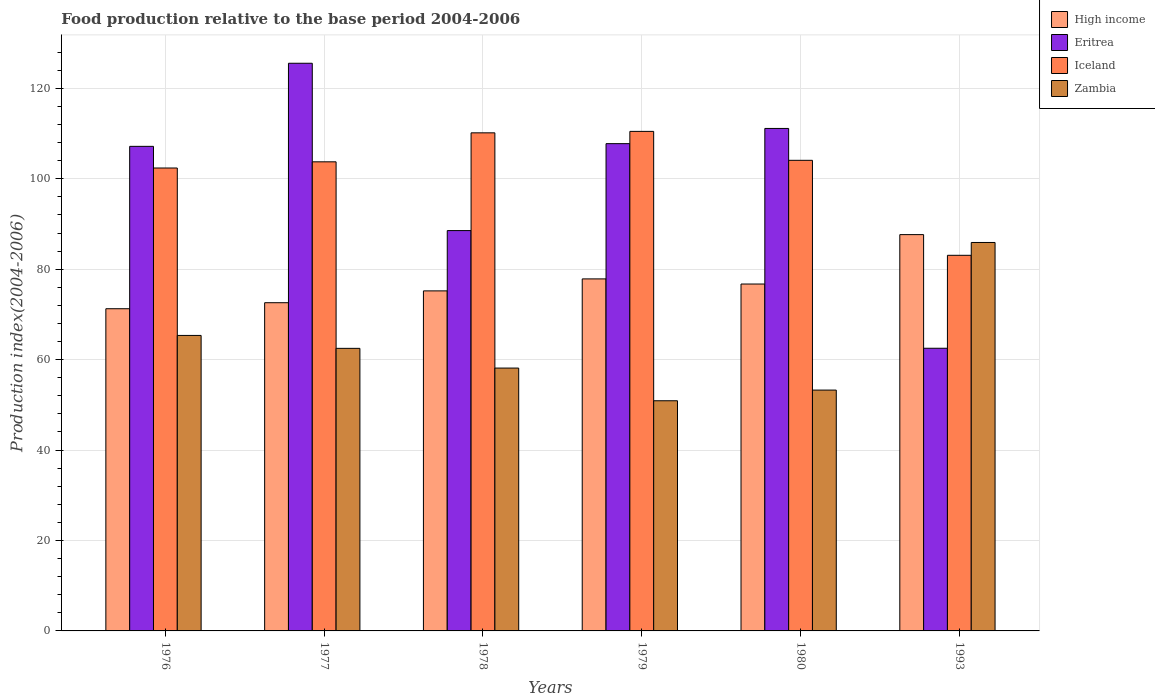Are the number of bars per tick equal to the number of legend labels?
Offer a very short reply. Yes. Are the number of bars on each tick of the X-axis equal?
Your response must be concise. Yes. What is the label of the 3rd group of bars from the left?
Make the answer very short. 1978. What is the food production index in Iceland in 1979?
Your response must be concise. 110.49. Across all years, what is the maximum food production index in Eritrea?
Your response must be concise. 125.56. Across all years, what is the minimum food production index in Zambia?
Your answer should be very brief. 50.91. In which year was the food production index in High income minimum?
Provide a succinct answer. 1976. What is the total food production index in High income in the graph?
Provide a succinct answer. 461.32. What is the difference between the food production index in Zambia in 1977 and that in 1978?
Keep it short and to the point. 4.36. What is the difference between the food production index in Zambia in 1978 and the food production index in High income in 1980?
Keep it short and to the point. -18.59. What is the average food production index in Zambia per year?
Ensure brevity in your answer.  62.68. In the year 1978, what is the difference between the food production index in Iceland and food production index in High income?
Your response must be concise. 34.96. What is the ratio of the food production index in Eritrea in 1978 to that in 1980?
Your response must be concise. 0.8. Is the food production index in High income in 1976 less than that in 1978?
Keep it short and to the point. Yes. What is the difference between the highest and the second highest food production index in Iceland?
Your response must be concise. 0.32. What is the difference between the highest and the lowest food production index in Eritrea?
Ensure brevity in your answer.  63.04. Is the sum of the food production index in Zambia in 1976 and 1977 greater than the maximum food production index in Iceland across all years?
Keep it short and to the point. Yes. How many years are there in the graph?
Offer a terse response. 6. Does the graph contain any zero values?
Your answer should be very brief. No. How many legend labels are there?
Provide a short and direct response. 4. What is the title of the graph?
Provide a short and direct response. Food production relative to the base period 2004-2006. What is the label or title of the Y-axis?
Your response must be concise. Production index(2004-2006). What is the Production index(2004-2006) in High income in 1976?
Offer a terse response. 71.26. What is the Production index(2004-2006) in Eritrea in 1976?
Your response must be concise. 107.18. What is the Production index(2004-2006) of Iceland in 1976?
Offer a very short reply. 102.39. What is the Production index(2004-2006) in Zambia in 1976?
Keep it short and to the point. 65.36. What is the Production index(2004-2006) of High income in 1977?
Keep it short and to the point. 72.6. What is the Production index(2004-2006) of Eritrea in 1977?
Your answer should be compact. 125.56. What is the Production index(2004-2006) in Iceland in 1977?
Provide a short and direct response. 103.76. What is the Production index(2004-2006) of Zambia in 1977?
Make the answer very short. 62.5. What is the Production index(2004-2006) in High income in 1978?
Ensure brevity in your answer.  75.21. What is the Production index(2004-2006) in Eritrea in 1978?
Your answer should be compact. 88.55. What is the Production index(2004-2006) in Iceland in 1978?
Your answer should be compact. 110.17. What is the Production index(2004-2006) of Zambia in 1978?
Ensure brevity in your answer.  58.14. What is the Production index(2004-2006) of High income in 1979?
Offer a terse response. 77.86. What is the Production index(2004-2006) in Eritrea in 1979?
Your answer should be compact. 107.78. What is the Production index(2004-2006) of Iceland in 1979?
Make the answer very short. 110.49. What is the Production index(2004-2006) in Zambia in 1979?
Ensure brevity in your answer.  50.91. What is the Production index(2004-2006) of High income in 1980?
Provide a succinct answer. 76.73. What is the Production index(2004-2006) in Eritrea in 1980?
Your answer should be very brief. 111.14. What is the Production index(2004-2006) in Iceland in 1980?
Offer a terse response. 104.09. What is the Production index(2004-2006) in Zambia in 1980?
Keep it short and to the point. 53.27. What is the Production index(2004-2006) in High income in 1993?
Keep it short and to the point. 87.66. What is the Production index(2004-2006) in Eritrea in 1993?
Your answer should be compact. 62.52. What is the Production index(2004-2006) of Iceland in 1993?
Your response must be concise. 83.08. What is the Production index(2004-2006) in Zambia in 1993?
Ensure brevity in your answer.  85.92. Across all years, what is the maximum Production index(2004-2006) of High income?
Your response must be concise. 87.66. Across all years, what is the maximum Production index(2004-2006) of Eritrea?
Provide a succinct answer. 125.56. Across all years, what is the maximum Production index(2004-2006) of Iceland?
Your answer should be very brief. 110.49. Across all years, what is the maximum Production index(2004-2006) of Zambia?
Make the answer very short. 85.92. Across all years, what is the minimum Production index(2004-2006) in High income?
Your answer should be very brief. 71.26. Across all years, what is the minimum Production index(2004-2006) of Eritrea?
Provide a short and direct response. 62.52. Across all years, what is the minimum Production index(2004-2006) of Iceland?
Ensure brevity in your answer.  83.08. Across all years, what is the minimum Production index(2004-2006) of Zambia?
Your response must be concise. 50.91. What is the total Production index(2004-2006) of High income in the graph?
Ensure brevity in your answer.  461.32. What is the total Production index(2004-2006) in Eritrea in the graph?
Keep it short and to the point. 602.73. What is the total Production index(2004-2006) of Iceland in the graph?
Keep it short and to the point. 613.98. What is the total Production index(2004-2006) of Zambia in the graph?
Offer a terse response. 376.1. What is the difference between the Production index(2004-2006) of High income in 1976 and that in 1977?
Provide a succinct answer. -1.33. What is the difference between the Production index(2004-2006) in Eritrea in 1976 and that in 1977?
Offer a very short reply. -18.38. What is the difference between the Production index(2004-2006) in Iceland in 1976 and that in 1977?
Provide a succinct answer. -1.37. What is the difference between the Production index(2004-2006) in Zambia in 1976 and that in 1977?
Ensure brevity in your answer.  2.86. What is the difference between the Production index(2004-2006) in High income in 1976 and that in 1978?
Offer a terse response. -3.95. What is the difference between the Production index(2004-2006) of Eritrea in 1976 and that in 1978?
Your answer should be compact. 18.63. What is the difference between the Production index(2004-2006) of Iceland in 1976 and that in 1978?
Offer a terse response. -7.78. What is the difference between the Production index(2004-2006) in Zambia in 1976 and that in 1978?
Your answer should be compact. 7.22. What is the difference between the Production index(2004-2006) in High income in 1976 and that in 1979?
Keep it short and to the point. -6.6. What is the difference between the Production index(2004-2006) of Iceland in 1976 and that in 1979?
Your response must be concise. -8.1. What is the difference between the Production index(2004-2006) in Zambia in 1976 and that in 1979?
Your response must be concise. 14.45. What is the difference between the Production index(2004-2006) in High income in 1976 and that in 1980?
Provide a short and direct response. -5.47. What is the difference between the Production index(2004-2006) in Eritrea in 1976 and that in 1980?
Provide a short and direct response. -3.96. What is the difference between the Production index(2004-2006) in Iceland in 1976 and that in 1980?
Provide a succinct answer. -1.7. What is the difference between the Production index(2004-2006) in Zambia in 1976 and that in 1980?
Your answer should be compact. 12.09. What is the difference between the Production index(2004-2006) in High income in 1976 and that in 1993?
Offer a terse response. -16.39. What is the difference between the Production index(2004-2006) in Eritrea in 1976 and that in 1993?
Your answer should be compact. 44.66. What is the difference between the Production index(2004-2006) in Iceland in 1976 and that in 1993?
Keep it short and to the point. 19.31. What is the difference between the Production index(2004-2006) of Zambia in 1976 and that in 1993?
Keep it short and to the point. -20.56. What is the difference between the Production index(2004-2006) of High income in 1977 and that in 1978?
Ensure brevity in your answer.  -2.62. What is the difference between the Production index(2004-2006) in Eritrea in 1977 and that in 1978?
Provide a succinct answer. 37.01. What is the difference between the Production index(2004-2006) in Iceland in 1977 and that in 1978?
Keep it short and to the point. -6.41. What is the difference between the Production index(2004-2006) of Zambia in 1977 and that in 1978?
Your answer should be very brief. 4.36. What is the difference between the Production index(2004-2006) of High income in 1977 and that in 1979?
Keep it short and to the point. -5.27. What is the difference between the Production index(2004-2006) of Eritrea in 1977 and that in 1979?
Provide a succinct answer. 17.78. What is the difference between the Production index(2004-2006) of Iceland in 1977 and that in 1979?
Provide a short and direct response. -6.73. What is the difference between the Production index(2004-2006) in Zambia in 1977 and that in 1979?
Offer a very short reply. 11.59. What is the difference between the Production index(2004-2006) in High income in 1977 and that in 1980?
Give a very brief answer. -4.14. What is the difference between the Production index(2004-2006) in Eritrea in 1977 and that in 1980?
Provide a succinct answer. 14.42. What is the difference between the Production index(2004-2006) of Iceland in 1977 and that in 1980?
Ensure brevity in your answer.  -0.33. What is the difference between the Production index(2004-2006) of Zambia in 1977 and that in 1980?
Provide a succinct answer. 9.23. What is the difference between the Production index(2004-2006) of High income in 1977 and that in 1993?
Keep it short and to the point. -15.06. What is the difference between the Production index(2004-2006) in Eritrea in 1977 and that in 1993?
Provide a succinct answer. 63.04. What is the difference between the Production index(2004-2006) of Iceland in 1977 and that in 1993?
Your response must be concise. 20.68. What is the difference between the Production index(2004-2006) in Zambia in 1977 and that in 1993?
Provide a short and direct response. -23.42. What is the difference between the Production index(2004-2006) in High income in 1978 and that in 1979?
Provide a short and direct response. -2.65. What is the difference between the Production index(2004-2006) of Eritrea in 1978 and that in 1979?
Make the answer very short. -19.23. What is the difference between the Production index(2004-2006) of Iceland in 1978 and that in 1979?
Your response must be concise. -0.32. What is the difference between the Production index(2004-2006) in Zambia in 1978 and that in 1979?
Provide a short and direct response. 7.23. What is the difference between the Production index(2004-2006) in High income in 1978 and that in 1980?
Make the answer very short. -1.52. What is the difference between the Production index(2004-2006) of Eritrea in 1978 and that in 1980?
Offer a very short reply. -22.59. What is the difference between the Production index(2004-2006) of Iceland in 1978 and that in 1980?
Your answer should be compact. 6.08. What is the difference between the Production index(2004-2006) of Zambia in 1978 and that in 1980?
Provide a short and direct response. 4.87. What is the difference between the Production index(2004-2006) of High income in 1978 and that in 1993?
Offer a very short reply. -12.45. What is the difference between the Production index(2004-2006) of Eritrea in 1978 and that in 1993?
Ensure brevity in your answer.  26.03. What is the difference between the Production index(2004-2006) of Iceland in 1978 and that in 1993?
Give a very brief answer. 27.09. What is the difference between the Production index(2004-2006) in Zambia in 1978 and that in 1993?
Your response must be concise. -27.78. What is the difference between the Production index(2004-2006) of High income in 1979 and that in 1980?
Keep it short and to the point. 1.13. What is the difference between the Production index(2004-2006) in Eritrea in 1979 and that in 1980?
Offer a very short reply. -3.36. What is the difference between the Production index(2004-2006) of Zambia in 1979 and that in 1980?
Provide a succinct answer. -2.36. What is the difference between the Production index(2004-2006) in High income in 1979 and that in 1993?
Give a very brief answer. -9.79. What is the difference between the Production index(2004-2006) of Eritrea in 1979 and that in 1993?
Give a very brief answer. 45.26. What is the difference between the Production index(2004-2006) in Iceland in 1979 and that in 1993?
Keep it short and to the point. 27.41. What is the difference between the Production index(2004-2006) of Zambia in 1979 and that in 1993?
Your answer should be compact. -35.01. What is the difference between the Production index(2004-2006) in High income in 1980 and that in 1993?
Offer a very short reply. -10.93. What is the difference between the Production index(2004-2006) in Eritrea in 1980 and that in 1993?
Ensure brevity in your answer.  48.62. What is the difference between the Production index(2004-2006) of Iceland in 1980 and that in 1993?
Offer a terse response. 21.01. What is the difference between the Production index(2004-2006) of Zambia in 1980 and that in 1993?
Keep it short and to the point. -32.65. What is the difference between the Production index(2004-2006) in High income in 1976 and the Production index(2004-2006) in Eritrea in 1977?
Provide a succinct answer. -54.3. What is the difference between the Production index(2004-2006) in High income in 1976 and the Production index(2004-2006) in Iceland in 1977?
Keep it short and to the point. -32.5. What is the difference between the Production index(2004-2006) of High income in 1976 and the Production index(2004-2006) of Zambia in 1977?
Offer a terse response. 8.76. What is the difference between the Production index(2004-2006) of Eritrea in 1976 and the Production index(2004-2006) of Iceland in 1977?
Your response must be concise. 3.42. What is the difference between the Production index(2004-2006) in Eritrea in 1976 and the Production index(2004-2006) in Zambia in 1977?
Ensure brevity in your answer.  44.68. What is the difference between the Production index(2004-2006) of Iceland in 1976 and the Production index(2004-2006) of Zambia in 1977?
Give a very brief answer. 39.89. What is the difference between the Production index(2004-2006) in High income in 1976 and the Production index(2004-2006) in Eritrea in 1978?
Keep it short and to the point. -17.29. What is the difference between the Production index(2004-2006) of High income in 1976 and the Production index(2004-2006) of Iceland in 1978?
Keep it short and to the point. -38.91. What is the difference between the Production index(2004-2006) in High income in 1976 and the Production index(2004-2006) in Zambia in 1978?
Make the answer very short. 13.12. What is the difference between the Production index(2004-2006) of Eritrea in 1976 and the Production index(2004-2006) of Iceland in 1978?
Ensure brevity in your answer.  -2.99. What is the difference between the Production index(2004-2006) in Eritrea in 1976 and the Production index(2004-2006) in Zambia in 1978?
Your response must be concise. 49.04. What is the difference between the Production index(2004-2006) in Iceland in 1976 and the Production index(2004-2006) in Zambia in 1978?
Offer a terse response. 44.25. What is the difference between the Production index(2004-2006) in High income in 1976 and the Production index(2004-2006) in Eritrea in 1979?
Ensure brevity in your answer.  -36.52. What is the difference between the Production index(2004-2006) in High income in 1976 and the Production index(2004-2006) in Iceland in 1979?
Your answer should be compact. -39.23. What is the difference between the Production index(2004-2006) in High income in 1976 and the Production index(2004-2006) in Zambia in 1979?
Ensure brevity in your answer.  20.35. What is the difference between the Production index(2004-2006) of Eritrea in 1976 and the Production index(2004-2006) of Iceland in 1979?
Ensure brevity in your answer.  -3.31. What is the difference between the Production index(2004-2006) in Eritrea in 1976 and the Production index(2004-2006) in Zambia in 1979?
Your answer should be compact. 56.27. What is the difference between the Production index(2004-2006) in Iceland in 1976 and the Production index(2004-2006) in Zambia in 1979?
Your answer should be very brief. 51.48. What is the difference between the Production index(2004-2006) in High income in 1976 and the Production index(2004-2006) in Eritrea in 1980?
Your answer should be compact. -39.88. What is the difference between the Production index(2004-2006) of High income in 1976 and the Production index(2004-2006) of Iceland in 1980?
Your answer should be compact. -32.83. What is the difference between the Production index(2004-2006) in High income in 1976 and the Production index(2004-2006) in Zambia in 1980?
Keep it short and to the point. 17.99. What is the difference between the Production index(2004-2006) of Eritrea in 1976 and the Production index(2004-2006) of Iceland in 1980?
Provide a short and direct response. 3.09. What is the difference between the Production index(2004-2006) of Eritrea in 1976 and the Production index(2004-2006) of Zambia in 1980?
Provide a succinct answer. 53.91. What is the difference between the Production index(2004-2006) in Iceland in 1976 and the Production index(2004-2006) in Zambia in 1980?
Give a very brief answer. 49.12. What is the difference between the Production index(2004-2006) of High income in 1976 and the Production index(2004-2006) of Eritrea in 1993?
Give a very brief answer. 8.74. What is the difference between the Production index(2004-2006) of High income in 1976 and the Production index(2004-2006) of Iceland in 1993?
Give a very brief answer. -11.82. What is the difference between the Production index(2004-2006) in High income in 1976 and the Production index(2004-2006) in Zambia in 1993?
Your response must be concise. -14.66. What is the difference between the Production index(2004-2006) of Eritrea in 1976 and the Production index(2004-2006) of Iceland in 1993?
Your response must be concise. 24.1. What is the difference between the Production index(2004-2006) of Eritrea in 1976 and the Production index(2004-2006) of Zambia in 1993?
Give a very brief answer. 21.26. What is the difference between the Production index(2004-2006) in Iceland in 1976 and the Production index(2004-2006) in Zambia in 1993?
Make the answer very short. 16.47. What is the difference between the Production index(2004-2006) of High income in 1977 and the Production index(2004-2006) of Eritrea in 1978?
Offer a terse response. -15.95. What is the difference between the Production index(2004-2006) of High income in 1977 and the Production index(2004-2006) of Iceland in 1978?
Make the answer very short. -37.57. What is the difference between the Production index(2004-2006) in High income in 1977 and the Production index(2004-2006) in Zambia in 1978?
Your response must be concise. 14.46. What is the difference between the Production index(2004-2006) in Eritrea in 1977 and the Production index(2004-2006) in Iceland in 1978?
Your answer should be very brief. 15.39. What is the difference between the Production index(2004-2006) of Eritrea in 1977 and the Production index(2004-2006) of Zambia in 1978?
Provide a succinct answer. 67.42. What is the difference between the Production index(2004-2006) of Iceland in 1977 and the Production index(2004-2006) of Zambia in 1978?
Your answer should be very brief. 45.62. What is the difference between the Production index(2004-2006) of High income in 1977 and the Production index(2004-2006) of Eritrea in 1979?
Provide a short and direct response. -35.18. What is the difference between the Production index(2004-2006) of High income in 1977 and the Production index(2004-2006) of Iceland in 1979?
Provide a short and direct response. -37.89. What is the difference between the Production index(2004-2006) in High income in 1977 and the Production index(2004-2006) in Zambia in 1979?
Your answer should be very brief. 21.69. What is the difference between the Production index(2004-2006) in Eritrea in 1977 and the Production index(2004-2006) in Iceland in 1979?
Provide a succinct answer. 15.07. What is the difference between the Production index(2004-2006) of Eritrea in 1977 and the Production index(2004-2006) of Zambia in 1979?
Give a very brief answer. 74.65. What is the difference between the Production index(2004-2006) of Iceland in 1977 and the Production index(2004-2006) of Zambia in 1979?
Provide a short and direct response. 52.85. What is the difference between the Production index(2004-2006) of High income in 1977 and the Production index(2004-2006) of Eritrea in 1980?
Your answer should be very brief. -38.54. What is the difference between the Production index(2004-2006) of High income in 1977 and the Production index(2004-2006) of Iceland in 1980?
Provide a succinct answer. -31.49. What is the difference between the Production index(2004-2006) in High income in 1977 and the Production index(2004-2006) in Zambia in 1980?
Your response must be concise. 19.33. What is the difference between the Production index(2004-2006) of Eritrea in 1977 and the Production index(2004-2006) of Iceland in 1980?
Your response must be concise. 21.47. What is the difference between the Production index(2004-2006) in Eritrea in 1977 and the Production index(2004-2006) in Zambia in 1980?
Keep it short and to the point. 72.29. What is the difference between the Production index(2004-2006) in Iceland in 1977 and the Production index(2004-2006) in Zambia in 1980?
Offer a terse response. 50.49. What is the difference between the Production index(2004-2006) of High income in 1977 and the Production index(2004-2006) of Eritrea in 1993?
Provide a succinct answer. 10.08. What is the difference between the Production index(2004-2006) in High income in 1977 and the Production index(2004-2006) in Iceland in 1993?
Give a very brief answer. -10.48. What is the difference between the Production index(2004-2006) in High income in 1977 and the Production index(2004-2006) in Zambia in 1993?
Your response must be concise. -13.32. What is the difference between the Production index(2004-2006) in Eritrea in 1977 and the Production index(2004-2006) in Iceland in 1993?
Your response must be concise. 42.48. What is the difference between the Production index(2004-2006) of Eritrea in 1977 and the Production index(2004-2006) of Zambia in 1993?
Keep it short and to the point. 39.64. What is the difference between the Production index(2004-2006) of Iceland in 1977 and the Production index(2004-2006) of Zambia in 1993?
Provide a short and direct response. 17.84. What is the difference between the Production index(2004-2006) in High income in 1978 and the Production index(2004-2006) in Eritrea in 1979?
Keep it short and to the point. -32.57. What is the difference between the Production index(2004-2006) of High income in 1978 and the Production index(2004-2006) of Iceland in 1979?
Provide a succinct answer. -35.28. What is the difference between the Production index(2004-2006) of High income in 1978 and the Production index(2004-2006) of Zambia in 1979?
Give a very brief answer. 24.3. What is the difference between the Production index(2004-2006) in Eritrea in 1978 and the Production index(2004-2006) in Iceland in 1979?
Your answer should be very brief. -21.94. What is the difference between the Production index(2004-2006) in Eritrea in 1978 and the Production index(2004-2006) in Zambia in 1979?
Offer a terse response. 37.64. What is the difference between the Production index(2004-2006) in Iceland in 1978 and the Production index(2004-2006) in Zambia in 1979?
Provide a succinct answer. 59.26. What is the difference between the Production index(2004-2006) of High income in 1978 and the Production index(2004-2006) of Eritrea in 1980?
Provide a succinct answer. -35.93. What is the difference between the Production index(2004-2006) of High income in 1978 and the Production index(2004-2006) of Iceland in 1980?
Offer a very short reply. -28.88. What is the difference between the Production index(2004-2006) in High income in 1978 and the Production index(2004-2006) in Zambia in 1980?
Provide a short and direct response. 21.94. What is the difference between the Production index(2004-2006) of Eritrea in 1978 and the Production index(2004-2006) of Iceland in 1980?
Offer a terse response. -15.54. What is the difference between the Production index(2004-2006) in Eritrea in 1978 and the Production index(2004-2006) in Zambia in 1980?
Keep it short and to the point. 35.28. What is the difference between the Production index(2004-2006) in Iceland in 1978 and the Production index(2004-2006) in Zambia in 1980?
Offer a terse response. 56.9. What is the difference between the Production index(2004-2006) in High income in 1978 and the Production index(2004-2006) in Eritrea in 1993?
Your answer should be compact. 12.69. What is the difference between the Production index(2004-2006) of High income in 1978 and the Production index(2004-2006) of Iceland in 1993?
Make the answer very short. -7.87. What is the difference between the Production index(2004-2006) in High income in 1978 and the Production index(2004-2006) in Zambia in 1993?
Offer a terse response. -10.71. What is the difference between the Production index(2004-2006) in Eritrea in 1978 and the Production index(2004-2006) in Iceland in 1993?
Give a very brief answer. 5.47. What is the difference between the Production index(2004-2006) in Eritrea in 1978 and the Production index(2004-2006) in Zambia in 1993?
Make the answer very short. 2.63. What is the difference between the Production index(2004-2006) of Iceland in 1978 and the Production index(2004-2006) of Zambia in 1993?
Your response must be concise. 24.25. What is the difference between the Production index(2004-2006) of High income in 1979 and the Production index(2004-2006) of Eritrea in 1980?
Ensure brevity in your answer.  -33.28. What is the difference between the Production index(2004-2006) in High income in 1979 and the Production index(2004-2006) in Iceland in 1980?
Provide a short and direct response. -26.23. What is the difference between the Production index(2004-2006) in High income in 1979 and the Production index(2004-2006) in Zambia in 1980?
Offer a very short reply. 24.59. What is the difference between the Production index(2004-2006) of Eritrea in 1979 and the Production index(2004-2006) of Iceland in 1980?
Your answer should be compact. 3.69. What is the difference between the Production index(2004-2006) of Eritrea in 1979 and the Production index(2004-2006) of Zambia in 1980?
Ensure brevity in your answer.  54.51. What is the difference between the Production index(2004-2006) of Iceland in 1979 and the Production index(2004-2006) of Zambia in 1980?
Provide a succinct answer. 57.22. What is the difference between the Production index(2004-2006) in High income in 1979 and the Production index(2004-2006) in Eritrea in 1993?
Offer a terse response. 15.34. What is the difference between the Production index(2004-2006) of High income in 1979 and the Production index(2004-2006) of Iceland in 1993?
Provide a succinct answer. -5.22. What is the difference between the Production index(2004-2006) in High income in 1979 and the Production index(2004-2006) in Zambia in 1993?
Offer a very short reply. -8.06. What is the difference between the Production index(2004-2006) of Eritrea in 1979 and the Production index(2004-2006) of Iceland in 1993?
Keep it short and to the point. 24.7. What is the difference between the Production index(2004-2006) of Eritrea in 1979 and the Production index(2004-2006) of Zambia in 1993?
Your response must be concise. 21.86. What is the difference between the Production index(2004-2006) of Iceland in 1979 and the Production index(2004-2006) of Zambia in 1993?
Your answer should be compact. 24.57. What is the difference between the Production index(2004-2006) in High income in 1980 and the Production index(2004-2006) in Eritrea in 1993?
Your response must be concise. 14.21. What is the difference between the Production index(2004-2006) in High income in 1980 and the Production index(2004-2006) in Iceland in 1993?
Your response must be concise. -6.35. What is the difference between the Production index(2004-2006) of High income in 1980 and the Production index(2004-2006) of Zambia in 1993?
Offer a terse response. -9.19. What is the difference between the Production index(2004-2006) of Eritrea in 1980 and the Production index(2004-2006) of Iceland in 1993?
Make the answer very short. 28.06. What is the difference between the Production index(2004-2006) of Eritrea in 1980 and the Production index(2004-2006) of Zambia in 1993?
Provide a short and direct response. 25.22. What is the difference between the Production index(2004-2006) of Iceland in 1980 and the Production index(2004-2006) of Zambia in 1993?
Provide a succinct answer. 18.17. What is the average Production index(2004-2006) of High income per year?
Offer a very short reply. 76.89. What is the average Production index(2004-2006) in Eritrea per year?
Offer a very short reply. 100.45. What is the average Production index(2004-2006) in Iceland per year?
Give a very brief answer. 102.33. What is the average Production index(2004-2006) of Zambia per year?
Provide a succinct answer. 62.68. In the year 1976, what is the difference between the Production index(2004-2006) in High income and Production index(2004-2006) in Eritrea?
Keep it short and to the point. -35.92. In the year 1976, what is the difference between the Production index(2004-2006) in High income and Production index(2004-2006) in Iceland?
Your answer should be compact. -31.13. In the year 1976, what is the difference between the Production index(2004-2006) in High income and Production index(2004-2006) in Zambia?
Provide a short and direct response. 5.9. In the year 1976, what is the difference between the Production index(2004-2006) in Eritrea and Production index(2004-2006) in Iceland?
Provide a short and direct response. 4.79. In the year 1976, what is the difference between the Production index(2004-2006) of Eritrea and Production index(2004-2006) of Zambia?
Provide a succinct answer. 41.82. In the year 1976, what is the difference between the Production index(2004-2006) of Iceland and Production index(2004-2006) of Zambia?
Your answer should be very brief. 37.03. In the year 1977, what is the difference between the Production index(2004-2006) in High income and Production index(2004-2006) in Eritrea?
Provide a short and direct response. -52.96. In the year 1977, what is the difference between the Production index(2004-2006) in High income and Production index(2004-2006) in Iceland?
Your answer should be compact. -31.16. In the year 1977, what is the difference between the Production index(2004-2006) in High income and Production index(2004-2006) in Zambia?
Provide a short and direct response. 10.1. In the year 1977, what is the difference between the Production index(2004-2006) of Eritrea and Production index(2004-2006) of Iceland?
Ensure brevity in your answer.  21.8. In the year 1977, what is the difference between the Production index(2004-2006) in Eritrea and Production index(2004-2006) in Zambia?
Ensure brevity in your answer.  63.06. In the year 1977, what is the difference between the Production index(2004-2006) of Iceland and Production index(2004-2006) of Zambia?
Your response must be concise. 41.26. In the year 1978, what is the difference between the Production index(2004-2006) of High income and Production index(2004-2006) of Eritrea?
Keep it short and to the point. -13.34. In the year 1978, what is the difference between the Production index(2004-2006) of High income and Production index(2004-2006) of Iceland?
Your answer should be compact. -34.96. In the year 1978, what is the difference between the Production index(2004-2006) in High income and Production index(2004-2006) in Zambia?
Provide a succinct answer. 17.07. In the year 1978, what is the difference between the Production index(2004-2006) in Eritrea and Production index(2004-2006) in Iceland?
Offer a very short reply. -21.62. In the year 1978, what is the difference between the Production index(2004-2006) of Eritrea and Production index(2004-2006) of Zambia?
Your answer should be compact. 30.41. In the year 1978, what is the difference between the Production index(2004-2006) in Iceland and Production index(2004-2006) in Zambia?
Keep it short and to the point. 52.03. In the year 1979, what is the difference between the Production index(2004-2006) of High income and Production index(2004-2006) of Eritrea?
Provide a succinct answer. -29.92. In the year 1979, what is the difference between the Production index(2004-2006) of High income and Production index(2004-2006) of Iceland?
Your answer should be compact. -32.63. In the year 1979, what is the difference between the Production index(2004-2006) in High income and Production index(2004-2006) in Zambia?
Offer a very short reply. 26.95. In the year 1979, what is the difference between the Production index(2004-2006) of Eritrea and Production index(2004-2006) of Iceland?
Give a very brief answer. -2.71. In the year 1979, what is the difference between the Production index(2004-2006) in Eritrea and Production index(2004-2006) in Zambia?
Provide a short and direct response. 56.87. In the year 1979, what is the difference between the Production index(2004-2006) in Iceland and Production index(2004-2006) in Zambia?
Offer a very short reply. 59.58. In the year 1980, what is the difference between the Production index(2004-2006) of High income and Production index(2004-2006) of Eritrea?
Offer a terse response. -34.41. In the year 1980, what is the difference between the Production index(2004-2006) in High income and Production index(2004-2006) in Iceland?
Provide a succinct answer. -27.36. In the year 1980, what is the difference between the Production index(2004-2006) of High income and Production index(2004-2006) of Zambia?
Make the answer very short. 23.46. In the year 1980, what is the difference between the Production index(2004-2006) of Eritrea and Production index(2004-2006) of Iceland?
Offer a very short reply. 7.05. In the year 1980, what is the difference between the Production index(2004-2006) of Eritrea and Production index(2004-2006) of Zambia?
Your answer should be compact. 57.87. In the year 1980, what is the difference between the Production index(2004-2006) in Iceland and Production index(2004-2006) in Zambia?
Keep it short and to the point. 50.82. In the year 1993, what is the difference between the Production index(2004-2006) in High income and Production index(2004-2006) in Eritrea?
Offer a very short reply. 25.14. In the year 1993, what is the difference between the Production index(2004-2006) of High income and Production index(2004-2006) of Iceland?
Your answer should be very brief. 4.58. In the year 1993, what is the difference between the Production index(2004-2006) in High income and Production index(2004-2006) in Zambia?
Your response must be concise. 1.74. In the year 1993, what is the difference between the Production index(2004-2006) in Eritrea and Production index(2004-2006) in Iceland?
Your answer should be compact. -20.56. In the year 1993, what is the difference between the Production index(2004-2006) in Eritrea and Production index(2004-2006) in Zambia?
Offer a very short reply. -23.4. In the year 1993, what is the difference between the Production index(2004-2006) of Iceland and Production index(2004-2006) of Zambia?
Provide a succinct answer. -2.84. What is the ratio of the Production index(2004-2006) in High income in 1976 to that in 1977?
Your answer should be very brief. 0.98. What is the ratio of the Production index(2004-2006) in Eritrea in 1976 to that in 1977?
Offer a very short reply. 0.85. What is the ratio of the Production index(2004-2006) of Iceland in 1976 to that in 1977?
Your answer should be very brief. 0.99. What is the ratio of the Production index(2004-2006) of Zambia in 1976 to that in 1977?
Your answer should be compact. 1.05. What is the ratio of the Production index(2004-2006) of High income in 1976 to that in 1978?
Provide a short and direct response. 0.95. What is the ratio of the Production index(2004-2006) of Eritrea in 1976 to that in 1978?
Keep it short and to the point. 1.21. What is the ratio of the Production index(2004-2006) of Iceland in 1976 to that in 1978?
Your answer should be very brief. 0.93. What is the ratio of the Production index(2004-2006) of Zambia in 1976 to that in 1978?
Provide a succinct answer. 1.12. What is the ratio of the Production index(2004-2006) of High income in 1976 to that in 1979?
Your response must be concise. 0.92. What is the ratio of the Production index(2004-2006) of Iceland in 1976 to that in 1979?
Make the answer very short. 0.93. What is the ratio of the Production index(2004-2006) in Zambia in 1976 to that in 1979?
Offer a very short reply. 1.28. What is the ratio of the Production index(2004-2006) in High income in 1976 to that in 1980?
Provide a succinct answer. 0.93. What is the ratio of the Production index(2004-2006) in Eritrea in 1976 to that in 1980?
Keep it short and to the point. 0.96. What is the ratio of the Production index(2004-2006) of Iceland in 1976 to that in 1980?
Your answer should be very brief. 0.98. What is the ratio of the Production index(2004-2006) in Zambia in 1976 to that in 1980?
Your answer should be compact. 1.23. What is the ratio of the Production index(2004-2006) of High income in 1976 to that in 1993?
Offer a terse response. 0.81. What is the ratio of the Production index(2004-2006) of Eritrea in 1976 to that in 1993?
Offer a very short reply. 1.71. What is the ratio of the Production index(2004-2006) in Iceland in 1976 to that in 1993?
Keep it short and to the point. 1.23. What is the ratio of the Production index(2004-2006) in Zambia in 1976 to that in 1993?
Keep it short and to the point. 0.76. What is the ratio of the Production index(2004-2006) of High income in 1977 to that in 1978?
Offer a terse response. 0.97. What is the ratio of the Production index(2004-2006) of Eritrea in 1977 to that in 1978?
Your answer should be compact. 1.42. What is the ratio of the Production index(2004-2006) of Iceland in 1977 to that in 1978?
Keep it short and to the point. 0.94. What is the ratio of the Production index(2004-2006) of Zambia in 1977 to that in 1978?
Provide a succinct answer. 1.07. What is the ratio of the Production index(2004-2006) in High income in 1977 to that in 1979?
Offer a very short reply. 0.93. What is the ratio of the Production index(2004-2006) in Eritrea in 1977 to that in 1979?
Make the answer very short. 1.17. What is the ratio of the Production index(2004-2006) of Iceland in 1977 to that in 1979?
Offer a very short reply. 0.94. What is the ratio of the Production index(2004-2006) in Zambia in 1977 to that in 1979?
Your answer should be compact. 1.23. What is the ratio of the Production index(2004-2006) of High income in 1977 to that in 1980?
Keep it short and to the point. 0.95. What is the ratio of the Production index(2004-2006) of Eritrea in 1977 to that in 1980?
Offer a very short reply. 1.13. What is the ratio of the Production index(2004-2006) of Iceland in 1977 to that in 1980?
Make the answer very short. 1. What is the ratio of the Production index(2004-2006) in Zambia in 1977 to that in 1980?
Provide a succinct answer. 1.17. What is the ratio of the Production index(2004-2006) in High income in 1977 to that in 1993?
Your answer should be very brief. 0.83. What is the ratio of the Production index(2004-2006) of Eritrea in 1977 to that in 1993?
Make the answer very short. 2.01. What is the ratio of the Production index(2004-2006) of Iceland in 1977 to that in 1993?
Give a very brief answer. 1.25. What is the ratio of the Production index(2004-2006) in Zambia in 1977 to that in 1993?
Provide a succinct answer. 0.73. What is the ratio of the Production index(2004-2006) of High income in 1978 to that in 1979?
Ensure brevity in your answer.  0.97. What is the ratio of the Production index(2004-2006) of Eritrea in 1978 to that in 1979?
Make the answer very short. 0.82. What is the ratio of the Production index(2004-2006) in Iceland in 1978 to that in 1979?
Offer a very short reply. 1. What is the ratio of the Production index(2004-2006) of Zambia in 1978 to that in 1979?
Give a very brief answer. 1.14. What is the ratio of the Production index(2004-2006) in High income in 1978 to that in 1980?
Your response must be concise. 0.98. What is the ratio of the Production index(2004-2006) in Eritrea in 1978 to that in 1980?
Ensure brevity in your answer.  0.8. What is the ratio of the Production index(2004-2006) of Iceland in 1978 to that in 1980?
Give a very brief answer. 1.06. What is the ratio of the Production index(2004-2006) in Zambia in 1978 to that in 1980?
Give a very brief answer. 1.09. What is the ratio of the Production index(2004-2006) in High income in 1978 to that in 1993?
Your answer should be compact. 0.86. What is the ratio of the Production index(2004-2006) of Eritrea in 1978 to that in 1993?
Provide a succinct answer. 1.42. What is the ratio of the Production index(2004-2006) of Iceland in 1978 to that in 1993?
Provide a succinct answer. 1.33. What is the ratio of the Production index(2004-2006) of Zambia in 1978 to that in 1993?
Your answer should be very brief. 0.68. What is the ratio of the Production index(2004-2006) of High income in 1979 to that in 1980?
Provide a succinct answer. 1.01. What is the ratio of the Production index(2004-2006) of Eritrea in 1979 to that in 1980?
Your response must be concise. 0.97. What is the ratio of the Production index(2004-2006) of Iceland in 1979 to that in 1980?
Give a very brief answer. 1.06. What is the ratio of the Production index(2004-2006) of Zambia in 1979 to that in 1980?
Give a very brief answer. 0.96. What is the ratio of the Production index(2004-2006) of High income in 1979 to that in 1993?
Ensure brevity in your answer.  0.89. What is the ratio of the Production index(2004-2006) in Eritrea in 1979 to that in 1993?
Keep it short and to the point. 1.72. What is the ratio of the Production index(2004-2006) in Iceland in 1979 to that in 1993?
Offer a very short reply. 1.33. What is the ratio of the Production index(2004-2006) in Zambia in 1979 to that in 1993?
Ensure brevity in your answer.  0.59. What is the ratio of the Production index(2004-2006) in High income in 1980 to that in 1993?
Your answer should be very brief. 0.88. What is the ratio of the Production index(2004-2006) of Eritrea in 1980 to that in 1993?
Provide a succinct answer. 1.78. What is the ratio of the Production index(2004-2006) in Iceland in 1980 to that in 1993?
Provide a short and direct response. 1.25. What is the ratio of the Production index(2004-2006) in Zambia in 1980 to that in 1993?
Provide a short and direct response. 0.62. What is the difference between the highest and the second highest Production index(2004-2006) in High income?
Your answer should be compact. 9.79. What is the difference between the highest and the second highest Production index(2004-2006) in Eritrea?
Offer a terse response. 14.42. What is the difference between the highest and the second highest Production index(2004-2006) in Iceland?
Provide a short and direct response. 0.32. What is the difference between the highest and the second highest Production index(2004-2006) in Zambia?
Your response must be concise. 20.56. What is the difference between the highest and the lowest Production index(2004-2006) in High income?
Your answer should be compact. 16.39. What is the difference between the highest and the lowest Production index(2004-2006) of Eritrea?
Offer a terse response. 63.04. What is the difference between the highest and the lowest Production index(2004-2006) in Iceland?
Offer a terse response. 27.41. What is the difference between the highest and the lowest Production index(2004-2006) in Zambia?
Keep it short and to the point. 35.01. 